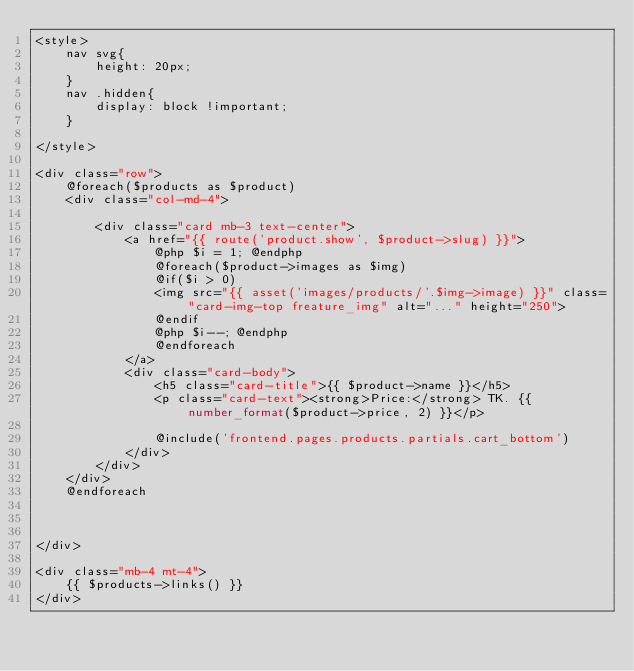<code> <loc_0><loc_0><loc_500><loc_500><_PHP_><style>
    nav svg{
        height: 20px;
    }
    nav .hidden{
        display: block !important;
    }

</style>

<div class="row">
    @foreach($products as $product)
    <div class="col-md-4">

        <div class="card mb-3 text-center">
            <a href="{{ route('product.show', $product->slug) }}">
                @php $i = 1; @endphp
                @foreach($product->images as $img)
                @if($i > 0)
                <img src="{{ asset('images/products/'.$img->image) }}" class="card-img-top freature_img" alt="..." height="250">
                @endif
                @php $i--; @endphp
                @endforeach
            </a>
            <div class="card-body">
                <h5 class="card-title">{{ $product->name }}</h5>
                <p class="card-text"><strong>Price:</strong> TK. {{ number_format($product->price, 2) }}</p>
                
                @include('frontend.pages.products.partials.cart_bottom')
            </div>
        </div>
    </div>
    @endforeach



</div>

<div class="mb-4 mt-4">
    {{ $products->links() }}
</div></code> 